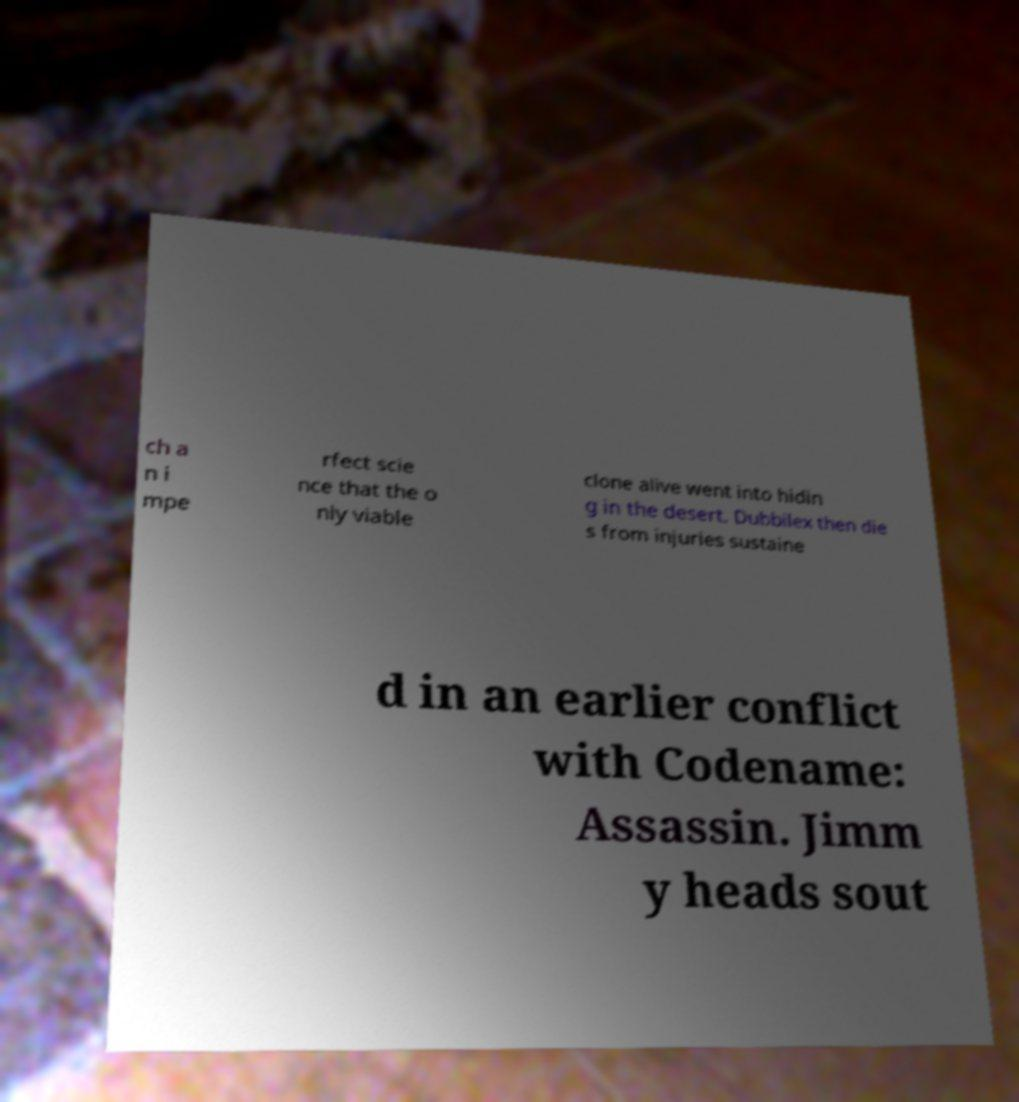What messages or text are displayed in this image? I need them in a readable, typed format. ch a n i mpe rfect scie nce that the o nly viable clone alive went into hidin g in the desert. Dubbilex then die s from injuries sustaine d in an earlier conflict with Codename: Assassin. Jimm y heads sout 